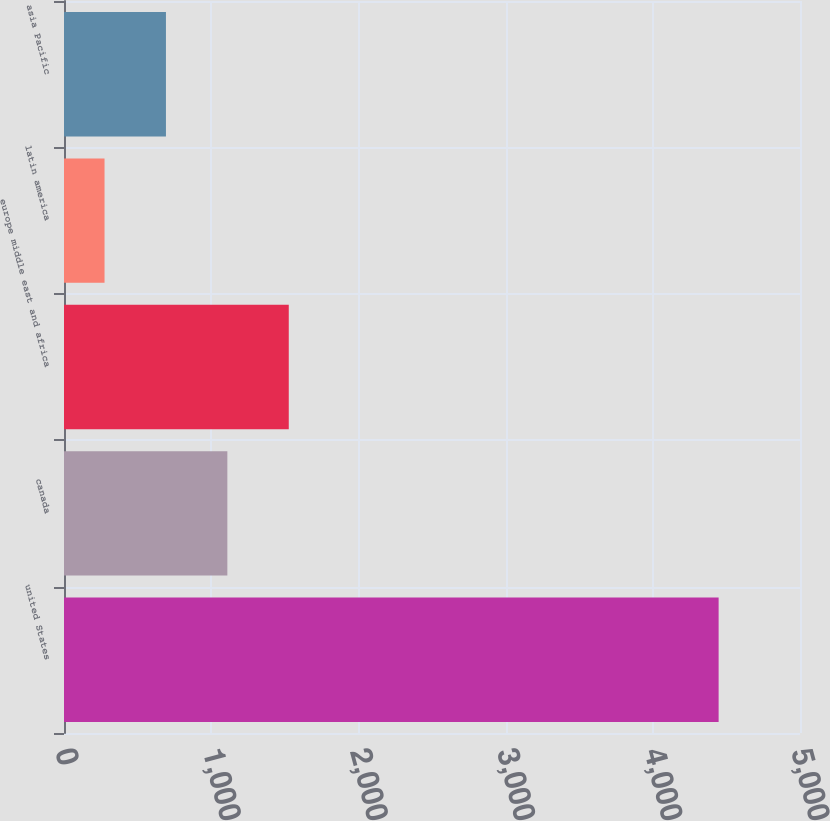<chart> <loc_0><loc_0><loc_500><loc_500><bar_chart><fcel>united States<fcel>canada<fcel>europe middle east and africa<fcel>latin america<fcel>asia Pacific<nl><fcel>4447.2<fcel>1109.76<fcel>1526.94<fcel>275.4<fcel>692.58<nl></chart> 